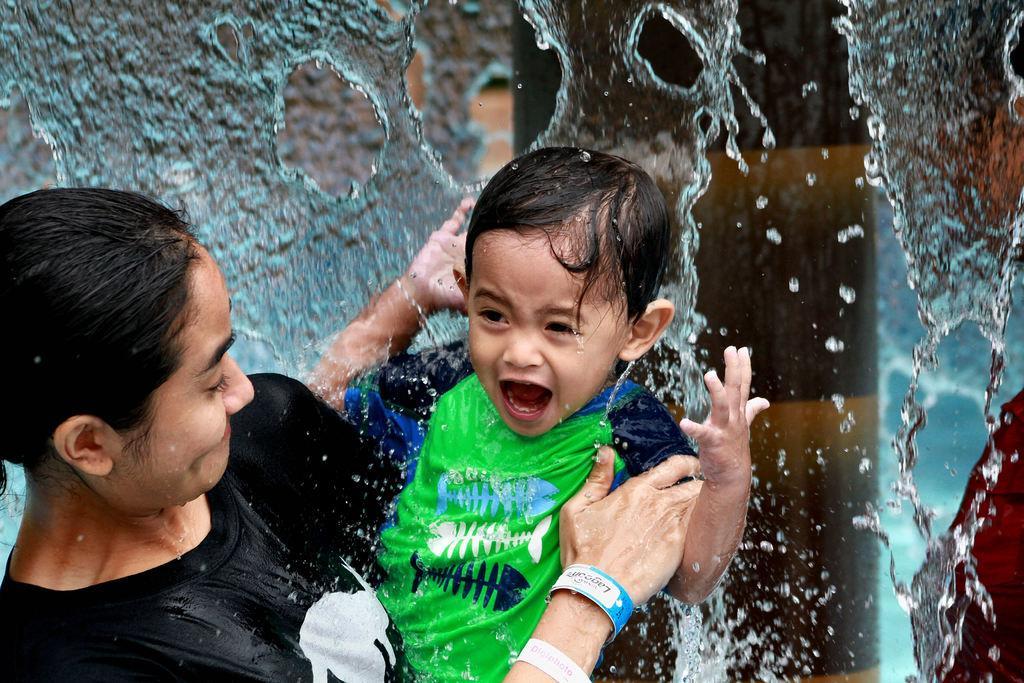Can you describe this image briefly? This image consists of a woman wearing a black T-shirt. She is holding a kid. At the top, there is water. In the background, it looks like a pillar. 